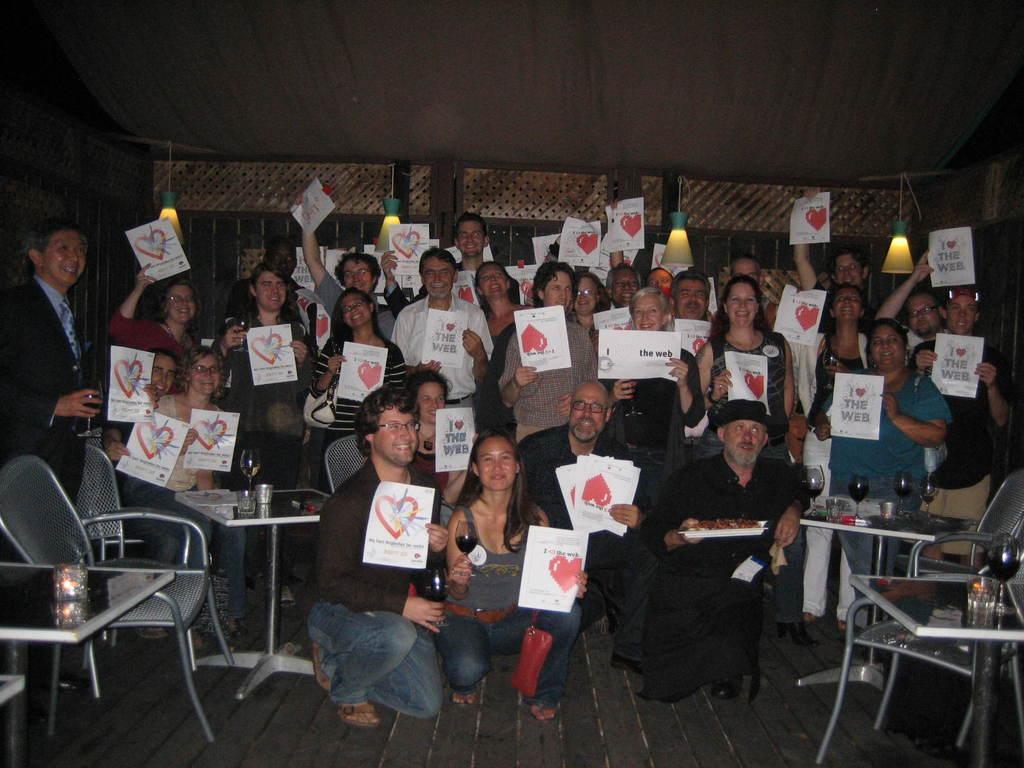In one or two sentences, can you explain what this image depicts? There is a group of people. They are smiling and holding a papers. Some persons are standing and some persons are sitting like squat position. There is a table on the right side. There is a glass on a table. There is a another table on the left side. We can see in the background wall. 